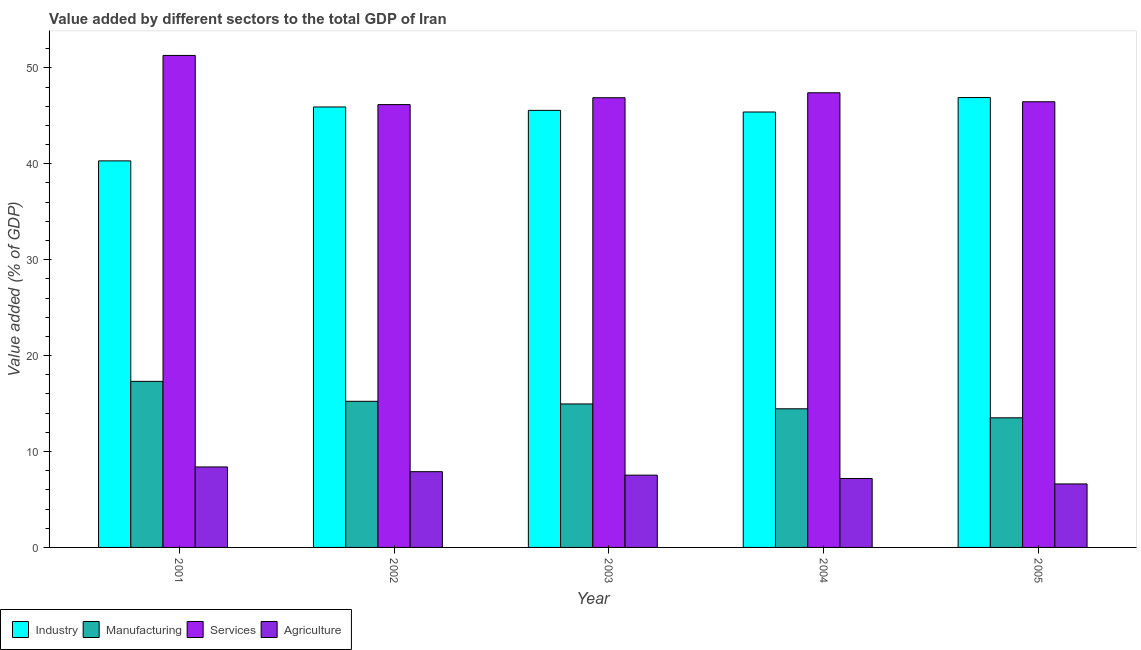How many different coloured bars are there?
Make the answer very short. 4. Are the number of bars per tick equal to the number of legend labels?
Ensure brevity in your answer.  Yes. Are the number of bars on each tick of the X-axis equal?
Give a very brief answer. Yes. How many bars are there on the 2nd tick from the right?
Provide a succinct answer. 4. What is the label of the 2nd group of bars from the left?
Give a very brief answer. 2002. What is the value added by services sector in 2003?
Give a very brief answer. 46.89. Across all years, what is the maximum value added by services sector?
Your answer should be compact. 51.3. Across all years, what is the minimum value added by manufacturing sector?
Your answer should be compact. 13.51. In which year was the value added by industrial sector maximum?
Your answer should be very brief. 2005. In which year was the value added by services sector minimum?
Offer a terse response. 2002. What is the total value added by industrial sector in the graph?
Offer a very short reply. 224.12. What is the difference between the value added by manufacturing sector in 2003 and that in 2004?
Your answer should be very brief. 0.51. What is the difference between the value added by services sector in 2003 and the value added by manufacturing sector in 2001?
Make the answer very short. -4.41. What is the average value added by industrial sector per year?
Your response must be concise. 44.82. In the year 2003, what is the difference between the value added by agricultural sector and value added by industrial sector?
Your response must be concise. 0. In how many years, is the value added by services sector greater than 18 %?
Ensure brevity in your answer.  5. What is the ratio of the value added by services sector in 2001 to that in 2003?
Offer a very short reply. 1.09. What is the difference between the highest and the second highest value added by services sector?
Ensure brevity in your answer.  3.89. What is the difference between the highest and the lowest value added by agricultural sector?
Ensure brevity in your answer.  1.77. In how many years, is the value added by services sector greater than the average value added by services sector taken over all years?
Offer a terse response. 1. What does the 1st bar from the left in 2002 represents?
Ensure brevity in your answer.  Industry. What does the 1st bar from the right in 2005 represents?
Offer a terse response. Agriculture. Is it the case that in every year, the sum of the value added by industrial sector and value added by manufacturing sector is greater than the value added by services sector?
Give a very brief answer. Yes. How many bars are there?
Ensure brevity in your answer.  20. What is the difference between two consecutive major ticks on the Y-axis?
Your response must be concise. 10. How are the legend labels stacked?
Offer a terse response. Horizontal. What is the title of the graph?
Offer a terse response. Value added by different sectors to the total GDP of Iran. What is the label or title of the Y-axis?
Your answer should be very brief. Value added (% of GDP). What is the Value added (% of GDP) of Industry in 2001?
Provide a succinct answer. 40.31. What is the Value added (% of GDP) in Manufacturing in 2001?
Give a very brief answer. 17.32. What is the Value added (% of GDP) in Services in 2001?
Provide a short and direct response. 51.3. What is the Value added (% of GDP) in Agriculture in 2001?
Offer a terse response. 8.39. What is the Value added (% of GDP) of Industry in 2002?
Keep it short and to the point. 45.93. What is the Value added (% of GDP) in Manufacturing in 2002?
Your answer should be compact. 15.24. What is the Value added (% of GDP) of Services in 2002?
Your response must be concise. 46.18. What is the Value added (% of GDP) in Agriculture in 2002?
Provide a succinct answer. 7.9. What is the Value added (% of GDP) of Industry in 2003?
Your response must be concise. 45.57. What is the Value added (% of GDP) in Manufacturing in 2003?
Offer a terse response. 14.96. What is the Value added (% of GDP) in Services in 2003?
Offer a terse response. 46.89. What is the Value added (% of GDP) of Agriculture in 2003?
Your answer should be compact. 7.54. What is the Value added (% of GDP) in Industry in 2004?
Provide a short and direct response. 45.4. What is the Value added (% of GDP) in Manufacturing in 2004?
Offer a terse response. 14.46. What is the Value added (% of GDP) in Services in 2004?
Make the answer very short. 47.41. What is the Value added (% of GDP) of Agriculture in 2004?
Your response must be concise. 7.19. What is the Value added (% of GDP) of Industry in 2005?
Give a very brief answer. 46.91. What is the Value added (% of GDP) of Manufacturing in 2005?
Ensure brevity in your answer.  13.51. What is the Value added (% of GDP) in Services in 2005?
Offer a very short reply. 46.47. What is the Value added (% of GDP) of Agriculture in 2005?
Your response must be concise. 6.62. Across all years, what is the maximum Value added (% of GDP) of Industry?
Ensure brevity in your answer.  46.91. Across all years, what is the maximum Value added (% of GDP) of Manufacturing?
Offer a very short reply. 17.32. Across all years, what is the maximum Value added (% of GDP) in Services?
Provide a succinct answer. 51.3. Across all years, what is the maximum Value added (% of GDP) of Agriculture?
Your response must be concise. 8.39. Across all years, what is the minimum Value added (% of GDP) of Industry?
Offer a terse response. 40.31. Across all years, what is the minimum Value added (% of GDP) of Manufacturing?
Keep it short and to the point. 13.51. Across all years, what is the minimum Value added (% of GDP) of Services?
Offer a terse response. 46.18. Across all years, what is the minimum Value added (% of GDP) in Agriculture?
Make the answer very short. 6.62. What is the total Value added (% of GDP) in Industry in the graph?
Ensure brevity in your answer.  224.12. What is the total Value added (% of GDP) in Manufacturing in the graph?
Provide a short and direct response. 75.48. What is the total Value added (% of GDP) in Services in the graph?
Give a very brief answer. 238.25. What is the total Value added (% of GDP) in Agriculture in the graph?
Make the answer very short. 37.64. What is the difference between the Value added (% of GDP) in Industry in 2001 and that in 2002?
Give a very brief answer. -5.62. What is the difference between the Value added (% of GDP) in Manufacturing in 2001 and that in 2002?
Provide a succinct answer. 2.08. What is the difference between the Value added (% of GDP) of Services in 2001 and that in 2002?
Keep it short and to the point. 5.13. What is the difference between the Value added (% of GDP) of Agriculture in 2001 and that in 2002?
Give a very brief answer. 0.49. What is the difference between the Value added (% of GDP) in Industry in 2001 and that in 2003?
Keep it short and to the point. -5.27. What is the difference between the Value added (% of GDP) in Manufacturing in 2001 and that in 2003?
Your response must be concise. 2.35. What is the difference between the Value added (% of GDP) in Services in 2001 and that in 2003?
Provide a short and direct response. 4.41. What is the difference between the Value added (% of GDP) of Agriculture in 2001 and that in 2003?
Ensure brevity in your answer.  0.86. What is the difference between the Value added (% of GDP) of Industry in 2001 and that in 2004?
Offer a very short reply. -5.1. What is the difference between the Value added (% of GDP) in Manufacturing in 2001 and that in 2004?
Make the answer very short. 2.86. What is the difference between the Value added (% of GDP) of Services in 2001 and that in 2004?
Keep it short and to the point. 3.89. What is the difference between the Value added (% of GDP) of Agriculture in 2001 and that in 2004?
Your response must be concise. 1.2. What is the difference between the Value added (% of GDP) of Industry in 2001 and that in 2005?
Give a very brief answer. -6.6. What is the difference between the Value added (% of GDP) of Manufacturing in 2001 and that in 2005?
Keep it short and to the point. 3.8. What is the difference between the Value added (% of GDP) of Services in 2001 and that in 2005?
Provide a short and direct response. 4.83. What is the difference between the Value added (% of GDP) of Agriculture in 2001 and that in 2005?
Your answer should be very brief. 1.77. What is the difference between the Value added (% of GDP) in Industry in 2002 and that in 2003?
Provide a short and direct response. 0.35. What is the difference between the Value added (% of GDP) in Manufacturing in 2002 and that in 2003?
Your answer should be compact. 0.28. What is the difference between the Value added (% of GDP) in Services in 2002 and that in 2003?
Ensure brevity in your answer.  -0.72. What is the difference between the Value added (% of GDP) of Agriculture in 2002 and that in 2003?
Provide a short and direct response. 0.36. What is the difference between the Value added (% of GDP) in Industry in 2002 and that in 2004?
Offer a terse response. 0.52. What is the difference between the Value added (% of GDP) of Manufacturing in 2002 and that in 2004?
Your response must be concise. 0.78. What is the difference between the Value added (% of GDP) in Services in 2002 and that in 2004?
Keep it short and to the point. -1.23. What is the difference between the Value added (% of GDP) of Agriculture in 2002 and that in 2004?
Provide a succinct answer. 0.71. What is the difference between the Value added (% of GDP) in Industry in 2002 and that in 2005?
Provide a succinct answer. -0.98. What is the difference between the Value added (% of GDP) of Manufacturing in 2002 and that in 2005?
Your response must be concise. 1.72. What is the difference between the Value added (% of GDP) of Services in 2002 and that in 2005?
Provide a short and direct response. -0.3. What is the difference between the Value added (% of GDP) of Agriculture in 2002 and that in 2005?
Provide a short and direct response. 1.28. What is the difference between the Value added (% of GDP) of Industry in 2003 and that in 2004?
Your answer should be very brief. 0.17. What is the difference between the Value added (% of GDP) in Manufacturing in 2003 and that in 2004?
Make the answer very short. 0.51. What is the difference between the Value added (% of GDP) in Services in 2003 and that in 2004?
Offer a very short reply. -0.52. What is the difference between the Value added (% of GDP) in Agriculture in 2003 and that in 2004?
Offer a very short reply. 0.35. What is the difference between the Value added (% of GDP) of Industry in 2003 and that in 2005?
Provide a succinct answer. -1.34. What is the difference between the Value added (% of GDP) of Manufacturing in 2003 and that in 2005?
Provide a succinct answer. 1.45. What is the difference between the Value added (% of GDP) of Services in 2003 and that in 2005?
Offer a terse response. 0.42. What is the difference between the Value added (% of GDP) in Agriculture in 2003 and that in 2005?
Provide a short and direct response. 0.92. What is the difference between the Value added (% of GDP) in Industry in 2004 and that in 2005?
Make the answer very short. -1.51. What is the difference between the Value added (% of GDP) of Manufacturing in 2004 and that in 2005?
Provide a succinct answer. 0.94. What is the difference between the Value added (% of GDP) in Services in 2004 and that in 2005?
Your answer should be compact. 0.94. What is the difference between the Value added (% of GDP) of Agriculture in 2004 and that in 2005?
Provide a succinct answer. 0.57. What is the difference between the Value added (% of GDP) in Industry in 2001 and the Value added (% of GDP) in Manufacturing in 2002?
Provide a succinct answer. 25.07. What is the difference between the Value added (% of GDP) in Industry in 2001 and the Value added (% of GDP) in Services in 2002?
Ensure brevity in your answer.  -5.87. What is the difference between the Value added (% of GDP) of Industry in 2001 and the Value added (% of GDP) of Agriculture in 2002?
Your answer should be compact. 32.41. What is the difference between the Value added (% of GDP) of Manufacturing in 2001 and the Value added (% of GDP) of Services in 2002?
Keep it short and to the point. -28.86. What is the difference between the Value added (% of GDP) in Manufacturing in 2001 and the Value added (% of GDP) in Agriculture in 2002?
Ensure brevity in your answer.  9.42. What is the difference between the Value added (% of GDP) in Services in 2001 and the Value added (% of GDP) in Agriculture in 2002?
Keep it short and to the point. 43.4. What is the difference between the Value added (% of GDP) of Industry in 2001 and the Value added (% of GDP) of Manufacturing in 2003?
Keep it short and to the point. 25.34. What is the difference between the Value added (% of GDP) of Industry in 2001 and the Value added (% of GDP) of Services in 2003?
Make the answer very short. -6.59. What is the difference between the Value added (% of GDP) in Industry in 2001 and the Value added (% of GDP) in Agriculture in 2003?
Provide a succinct answer. 32.77. What is the difference between the Value added (% of GDP) of Manufacturing in 2001 and the Value added (% of GDP) of Services in 2003?
Offer a terse response. -29.58. What is the difference between the Value added (% of GDP) of Manufacturing in 2001 and the Value added (% of GDP) of Agriculture in 2003?
Offer a terse response. 9.78. What is the difference between the Value added (% of GDP) in Services in 2001 and the Value added (% of GDP) in Agriculture in 2003?
Offer a very short reply. 43.77. What is the difference between the Value added (% of GDP) of Industry in 2001 and the Value added (% of GDP) of Manufacturing in 2004?
Keep it short and to the point. 25.85. What is the difference between the Value added (% of GDP) in Industry in 2001 and the Value added (% of GDP) in Services in 2004?
Ensure brevity in your answer.  -7.1. What is the difference between the Value added (% of GDP) in Industry in 2001 and the Value added (% of GDP) in Agriculture in 2004?
Keep it short and to the point. 33.12. What is the difference between the Value added (% of GDP) of Manufacturing in 2001 and the Value added (% of GDP) of Services in 2004?
Ensure brevity in your answer.  -30.09. What is the difference between the Value added (% of GDP) of Manufacturing in 2001 and the Value added (% of GDP) of Agriculture in 2004?
Provide a short and direct response. 10.13. What is the difference between the Value added (% of GDP) in Services in 2001 and the Value added (% of GDP) in Agriculture in 2004?
Your response must be concise. 44.11. What is the difference between the Value added (% of GDP) of Industry in 2001 and the Value added (% of GDP) of Manufacturing in 2005?
Keep it short and to the point. 26.79. What is the difference between the Value added (% of GDP) of Industry in 2001 and the Value added (% of GDP) of Services in 2005?
Provide a succinct answer. -6.17. What is the difference between the Value added (% of GDP) in Industry in 2001 and the Value added (% of GDP) in Agriculture in 2005?
Provide a succinct answer. 33.69. What is the difference between the Value added (% of GDP) in Manufacturing in 2001 and the Value added (% of GDP) in Services in 2005?
Provide a short and direct response. -29.16. What is the difference between the Value added (% of GDP) in Manufacturing in 2001 and the Value added (% of GDP) in Agriculture in 2005?
Provide a short and direct response. 10.69. What is the difference between the Value added (% of GDP) in Services in 2001 and the Value added (% of GDP) in Agriculture in 2005?
Provide a short and direct response. 44.68. What is the difference between the Value added (% of GDP) of Industry in 2002 and the Value added (% of GDP) of Manufacturing in 2003?
Offer a very short reply. 30.96. What is the difference between the Value added (% of GDP) in Industry in 2002 and the Value added (% of GDP) in Services in 2003?
Your answer should be compact. -0.96. What is the difference between the Value added (% of GDP) in Industry in 2002 and the Value added (% of GDP) in Agriculture in 2003?
Offer a terse response. 38.39. What is the difference between the Value added (% of GDP) of Manufacturing in 2002 and the Value added (% of GDP) of Services in 2003?
Give a very brief answer. -31.65. What is the difference between the Value added (% of GDP) in Manufacturing in 2002 and the Value added (% of GDP) in Agriculture in 2003?
Provide a succinct answer. 7.7. What is the difference between the Value added (% of GDP) in Services in 2002 and the Value added (% of GDP) in Agriculture in 2003?
Give a very brief answer. 38.64. What is the difference between the Value added (% of GDP) of Industry in 2002 and the Value added (% of GDP) of Manufacturing in 2004?
Give a very brief answer. 31.47. What is the difference between the Value added (% of GDP) in Industry in 2002 and the Value added (% of GDP) in Services in 2004?
Offer a terse response. -1.48. What is the difference between the Value added (% of GDP) of Industry in 2002 and the Value added (% of GDP) of Agriculture in 2004?
Provide a short and direct response. 38.74. What is the difference between the Value added (% of GDP) in Manufacturing in 2002 and the Value added (% of GDP) in Services in 2004?
Make the answer very short. -32.17. What is the difference between the Value added (% of GDP) of Manufacturing in 2002 and the Value added (% of GDP) of Agriculture in 2004?
Provide a succinct answer. 8.05. What is the difference between the Value added (% of GDP) of Services in 2002 and the Value added (% of GDP) of Agriculture in 2004?
Offer a very short reply. 38.99. What is the difference between the Value added (% of GDP) in Industry in 2002 and the Value added (% of GDP) in Manufacturing in 2005?
Make the answer very short. 32.41. What is the difference between the Value added (% of GDP) in Industry in 2002 and the Value added (% of GDP) in Services in 2005?
Offer a terse response. -0.54. What is the difference between the Value added (% of GDP) of Industry in 2002 and the Value added (% of GDP) of Agriculture in 2005?
Ensure brevity in your answer.  39.31. What is the difference between the Value added (% of GDP) of Manufacturing in 2002 and the Value added (% of GDP) of Services in 2005?
Keep it short and to the point. -31.23. What is the difference between the Value added (% of GDP) in Manufacturing in 2002 and the Value added (% of GDP) in Agriculture in 2005?
Offer a very short reply. 8.62. What is the difference between the Value added (% of GDP) in Services in 2002 and the Value added (% of GDP) in Agriculture in 2005?
Offer a terse response. 39.55. What is the difference between the Value added (% of GDP) in Industry in 2003 and the Value added (% of GDP) in Manufacturing in 2004?
Your response must be concise. 31.12. What is the difference between the Value added (% of GDP) of Industry in 2003 and the Value added (% of GDP) of Services in 2004?
Ensure brevity in your answer.  -1.84. What is the difference between the Value added (% of GDP) in Industry in 2003 and the Value added (% of GDP) in Agriculture in 2004?
Your answer should be compact. 38.38. What is the difference between the Value added (% of GDP) of Manufacturing in 2003 and the Value added (% of GDP) of Services in 2004?
Provide a short and direct response. -32.45. What is the difference between the Value added (% of GDP) in Manufacturing in 2003 and the Value added (% of GDP) in Agriculture in 2004?
Your response must be concise. 7.77. What is the difference between the Value added (% of GDP) in Services in 2003 and the Value added (% of GDP) in Agriculture in 2004?
Keep it short and to the point. 39.7. What is the difference between the Value added (% of GDP) in Industry in 2003 and the Value added (% of GDP) in Manufacturing in 2005?
Provide a succinct answer. 32.06. What is the difference between the Value added (% of GDP) of Industry in 2003 and the Value added (% of GDP) of Services in 2005?
Give a very brief answer. -0.9. What is the difference between the Value added (% of GDP) in Industry in 2003 and the Value added (% of GDP) in Agriculture in 2005?
Provide a short and direct response. 38.95. What is the difference between the Value added (% of GDP) of Manufacturing in 2003 and the Value added (% of GDP) of Services in 2005?
Ensure brevity in your answer.  -31.51. What is the difference between the Value added (% of GDP) of Manufacturing in 2003 and the Value added (% of GDP) of Agriculture in 2005?
Provide a succinct answer. 8.34. What is the difference between the Value added (% of GDP) in Services in 2003 and the Value added (% of GDP) in Agriculture in 2005?
Give a very brief answer. 40.27. What is the difference between the Value added (% of GDP) of Industry in 2004 and the Value added (% of GDP) of Manufacturing in 2005?
Your answer should be very brief. 31.89. What is the difference between the Value added (% of GDP) in Industry in 2004 and the Value added (% of GDP) in Services in 2005?
Provide a succinct answer. -1.07. What is the difference between the Value added (% of GDP) in Industry in 2004 and the Value added (% of GDP) in Agriculture in 2005?
Provide a succinct answer. 38.78. What is the difference between the Value added (% of GDP) of Manufacturing in 2004 and the Value added (% of GDP) of Services in 2005?
Keep it short and to the point. -32.01. What is the difference between the Value added (% of GDP) of Manufacturing in 2004 and the Value added (% of GDP) of Agriculture in 2005?
Offer a very short reply. 7.84. What is the difference between the Value added (% of GDP) of Services in 2004 and the Value added (% of GDP) of Agriculture in 2005?
Provide a short and direct response. 40.79. What is the average Value added (% of GDP) of Industry per year?
Make the answer very short. 44.82. What is the average Value added (% of GDP) in Manufacturing per year?
Your answer should be compact. 15.1. What is the average Value added (% of GDP) in Services per year?
Your answer should be compact. 47.65. What is the average Value added (% of GDP) of Agriculture per year?
Your response must be concise. 7.53. In the year 2001, what is the difference between the Value added (% of GDP) in Industry and Value added (% of GDP) in Manufacturing?
Your answer should be compact. 22.99. In the year 2001, what is the difference between the Value added (% of GDP) of Industry and Value added (% of GDP) of Services?
Make the answer very short. -11. In the year 2001, what is the difference between the Value added (% of GDP) in Industry and Value added (% of GDP) in Agriculture?
Offer a very short reply. 31.91. In the year 2001, what is the difference between the Value added (% of GDP) in Manufacturing and Value added (% of GDP) in Services?
Offer a very short reply. -33.99. In the year 2001, what is the difference between the Value added (% of GDP) of Manufacturing and Value added (% of GDP) of Agriculture?
Your response must be concise. 8.92. In the year 2001, what is the difference between the Value added (% of GDP) in Services and Value added (% of GDP) in Agriculture?
Your answer should be very brief. 42.91. In the year 2002, what is the difference between the Value added (% of GDP) of Industry and Value added (% of GDP) of Manufacturing?
Your response must be concise. 30.69. In the year 2002, what is the difference between the Value added (% of GDP) of Industry and Value added (% of GDP) of Services?
Your response must be concise. -0.25. In the year 2002, what is the difference between the Value added (% of GDP) in Industry and Value added (% of GDP) in Agriculture?
Your answer should be very brief. 38.03. In the year 2002, what is the difference between the Value added (% of GDP) of Manufacturing and Value added (% of GDP) of Services?
Offer a very short reply. -30.94. In the year 2002, what is the difference between the Value added (% of GDP) of Manufacturing and Value added (% of GDP) of Agriculture?
Provide a succinct answer. 7.34. In the year 2002, what is the difference between the Value added (% of GDP) of Services and Value added (% of GDP) of Agriculture?
Provide a succinct answer. 38.28. In the year 2003, what is the difference between the Value added (% of GDP) in Industry and Value added (% of GDP) in Manufacturing?
Make the answer very short. 30.61. In the year 2003, what is the difference between the Value added (% of GDP) of Industry and Value added (% of GDP) of Services?
Provide a short and direct response. -1.32. In the year 2003, what is the difference between the Value added (% of GDP) of Industry and Value added (% of GDP) of Agriculture?
Offer a terse response. 38.04. In the year 2003, what is the difference between the Value added (% of GDP) of Manufacturing and Value added (% of GDP) of Services?
Make the answer very short. -31.93. In the year 2003, what is the difference between the Value added (% of GDP) of Manufacturing and Value added (% of GDP) of Agriculture?
Your response must be concise. 7.43. In the year 2003, what is the difference between the Value added (% of GDP) of Services and Value added (% of GDP) of Agriculture?
Keep it short and to the point. 39.36. In the year 2004, what is the difference between the Value added (% of GDP) of Industry and Value added (% of GDP) of Manufacturing?
Provide a succinct answer. 30.95. In the year 2004, what is the difference between the Value added (% of GDP) of Industry and Value added (% of GDP) of Services?
Offer a terse response. -2.01. In the year 2004, what is the difference between the Value added (% of GDP) of Industry and Value added (% of GDP) of Agriculture?
Offer a very short reply. 38.21. In the year 2004, what is the difference between the Value added (% of GDP) in Manufacturing and Value added (% of GDP) in Services?
Ensure brevity in your answer.  -32.95. In the year 2004, what is the difference between the Value added (% of GDP) in Manufacturing and Value added (% of GDP) in Agriculture?
Offer a very short reply. 7.27. In the year 2004, what is the difference between the Value added (% of GDP) of Services and Value added (% of GDP) of Agriculture?
Ensure brevity in your answer.  40.22. In the year 2005, what is the difference between the Value added (% of GDP) in Industry and Value added (% of GDP) in Manufacturing?
Ensure brevity in your answer.  33.39. In the year 2005, what is the difference between the Value added (% of GDP) in Industry and Value added (% of GDP) in Services?
Provide a succinct answer. 0.44. In the year 2005, what is the difference between the Value added (% of GDP) of Industry and Value added (% of GDP) of Agriculture?
Offer a very short reply. 40.29. In the year 2005, what is the difference between the Value added (% of GDP) in Manufacturing and Value added (% of GDP) in Services?
Offer a very short reply. -32.96. In the year 2005, what is the difference between the Value added (% of GDP) in Manufacturing and Value added (% of GDP) in Agriculture?
Keep it short and to the point. 6.89. In the year 2005, what is the difference between the Value added (% of GDP) in Services and Value added (% of GDP) in Agriculture?
Make the answer very short. 39.85. What is the ratio of the Value added (% of GDP) in Industry in 2001 to that in 2002?
Make the answer very short. 0.88. What is the ratio of the Value added (% of GDP) of Manufacturing in 2001 to that in 2002?
Your answer should be compact. 1.14. What is the ratio of the Value added (% of GDP) of Services in 2001 to that in 2002?
Provide a short and direct response. 1.11. What is the ratio of the Value added (% of GDP) of Agriculture in 2001 to that in 2002?
Provide a short and direct response. 1.06. What is the ratio of the Value added (% of GDP) in Industry in 2001 to that in 2003?
Give a very brief answer. 0.88. What is the ratio of the Value added (% of GDP) in Manufacturing in 2001 to that in 2003?
Provide a short and direct response. 1.16. What is the ratio of the Value added (% of GDP) of Services in 2001 to that in 2003?
Keep it short and to the point. 1.09. What is the ratio of the Value added (% of GDP) in Agriculture in 2001 to that in 2003?
Keep it short and to the point. 1.11. What is the ratio of the Value added (% of GDP) in Industry in 2001 to that in 2004?
Offer a terse response. 0.89. What is the ratio of the Value added (% of GDP) of Manufacturing in 2001 to that in 2004?
Your response must be concise. 1.2. What is the ratio of the Value added (% of GDP) in Services in 2001 to that in 2004?
Give a very brief answer. 1.08. What is the ratio of the Value added (% of GDP) of Agriculture in 2001 to that in 2004?
Your response must be concise. 1.17. What is the ratio of the Value added (% of GDP) of Industry in 2001 to that in 2005?
Give a very brief answer. 0.86. What is the ratio of the Value added (% of GDP) of Manufacturing in 2001 to that in 2005?
Your response must be concise. 1.28. What is the ratio of the Value added (% of GDP) in Services in 2001 to that in 2005?
Provide a succinct answer. 1.1. What is the ratio of the Value added (% of GDP) of Agriculture in 2001 to that in 2005?
Your answer should be very brief. 1.27. What is the ratio of the Value added (% of GDP) in Manufacturing in 2002 to that in 2003?
Provide a succinct answer. 1.02. What is the ratio of the Value added (% of GDP) of Services in 2002 to that in 2003?
Make the answer very short. 0.98. What is the ratio of the Value added (% of GDP) of Agriculture in 2002 to that in 2003?
Keep it short and to the point. 1.05. What is the ratio of the Value added (% of GDP) in Industry in 2002 to that in 2004?
Offer a very short reply. 1.01. What is the ratio of the Value added (% of GDP) of Manufacturing in 2002 to that in 2004?
Provide a short and direct response. 1.05. What is the ratio of the Value added (% of GDP) of Agriculture in 2002 to that in 2004?
Provide a short and direct response. 1.1. What is the ratio of the Value added (% of GDP) in Industry in 2002 to that in 2005?
Make the answer very short. 0.98. What is the ratio of the Value added (% of GDP) in Manufacturing in 2002 to that in 2005?
Your answer should be very brief. 1.13. What is the ratio of the Value added (% of GDP) in Agriculture in 2002 to that in 2005?
Offer a terse response. 1.19. What is the ratio of the Value added (% of GDP) of Manufacturing in 2003 to that in 2004?
Offer a terse response. 1.03. What is the ratio of the Value added (% of GDP) of Agriculture in 2003 to that in 2004?
Your answer should be very brief. 1.05. What is the ratio of the Value added (% of GDP) of Industry in 2003 to that in 2005?
Your answer should be very brief. 0.97. What is the ratio of the Value added (% of GDP) of Manufacturing in 2003 to that in 2005?
Make the answer very short. 1.11. What is the ratio of the Value added (% of GDP) of Services in 2003 to that in 2005?
Your answer should be compact. 1.01. What is the ratio of the Value added (% of GDP) in Agriculture in 2003 to that in 2005?
Keep it short and to the point. 1.14. What is the ratio of the Value added (% of GDP) of Industry in 2004 to that in 2005?
Your response must be concise. 0.97. What is the ratio of the Value added (% of GDP) of Manufacturing in 2004 to that in 2005?
Provide a short and direct response. 1.07. What is the ratio of the Value added (% of GDP) of Services in 2004 to that in 2005?
Your answer should be very brief. 1.02. What is the ratio of the Value added (% of GDP) in Agriculture in 2004 to that in 2005?
Make the answer very short. 1.09. What is the difference between the highest and the second highest Value added (% of GDP) in Industry?
Offer a terse response. 0.98. What is the difference between the highest and the second highest Value added (% of GDP) in Manufacturing?
Ensure brevity in your answer.  2.08. What is the difference between the highest and the second highest Value added (% of GDP) of Services?
Offer a terse response. 3.89. What is the difference between the highest and the second highest Value added (% of GDP) of Agriculture?
Give a very brief answer. 0.49. What is the difference between the highest and the lowest Value added (% of GDP) of Industry?
Offer a terse response. 6.6. What is the difference between the highest and the lowest Value added (% of GDP) of Manufacturing?
Offer a very short reply. 3.8. What is the difference between the highest and the lowest Value added (% of GDP) of Services?
Your response must be concise. 5.13. What is the difference between the highest and the lowest Value added (% of GDP) in Agriculture?
Make the answer very short. 1.77. 